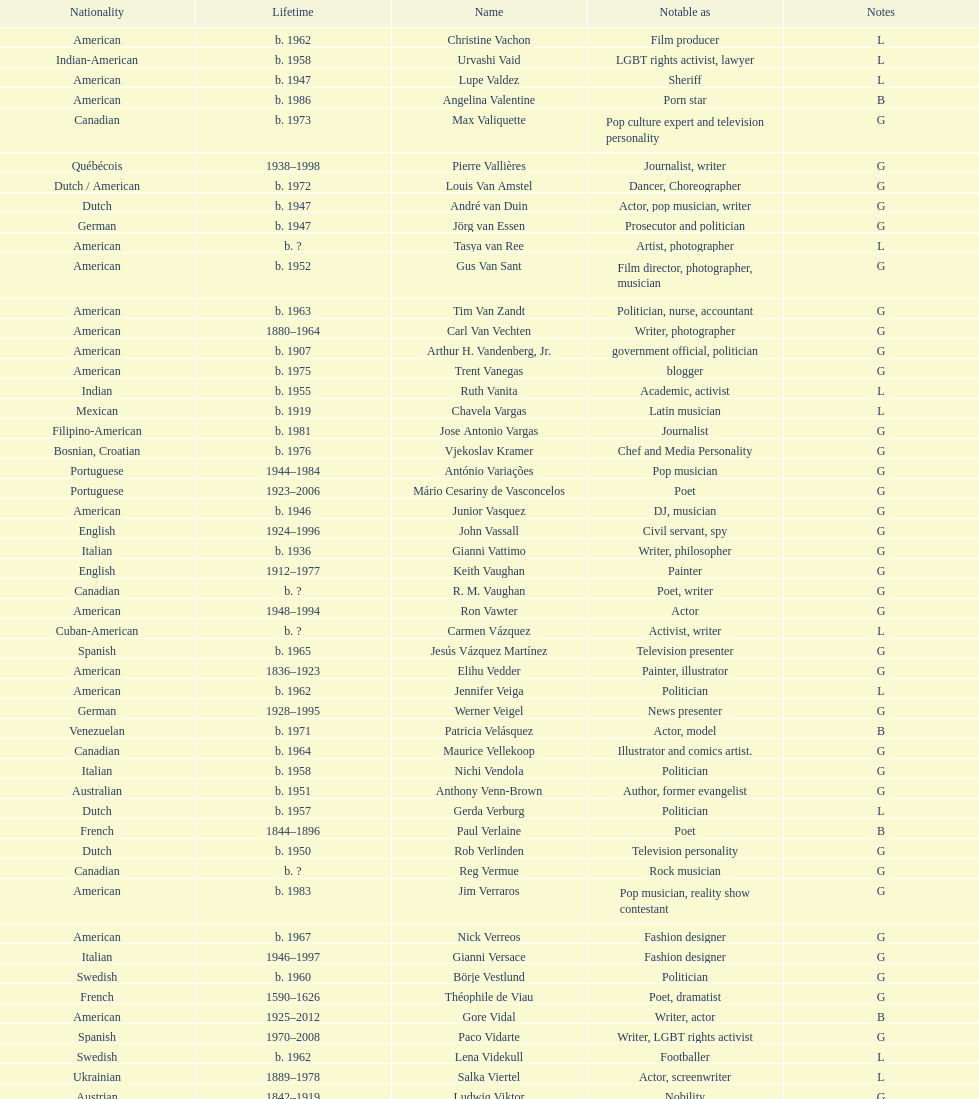What is the number of individuals in this group who were indian? 1. 